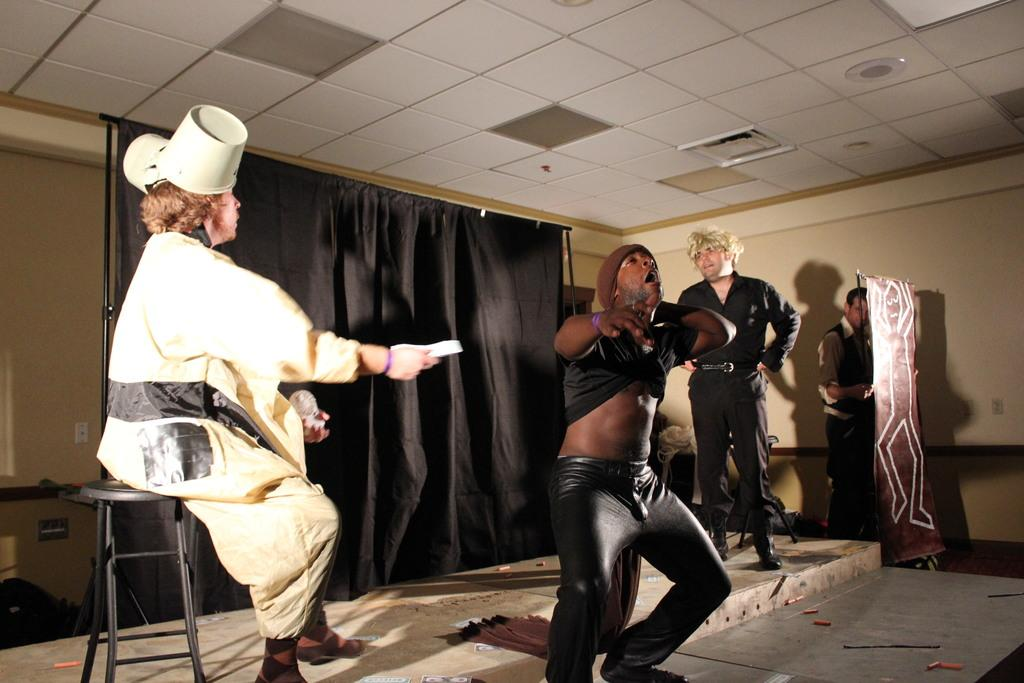How many people are performing on the stage in the image? There are four men in the image, and they are performing an act on a stage. What can be seen behind the performers on the stage? There is a black curtain in the background. What part of the room is visible above the stage? The ceiling is visible in the image. What is used to illuminate the stage in the image? There are lights in the image. What time of day is it during the performance in the image? The time of day is not mentioned or depicted in the image, so it cannot be determined. 